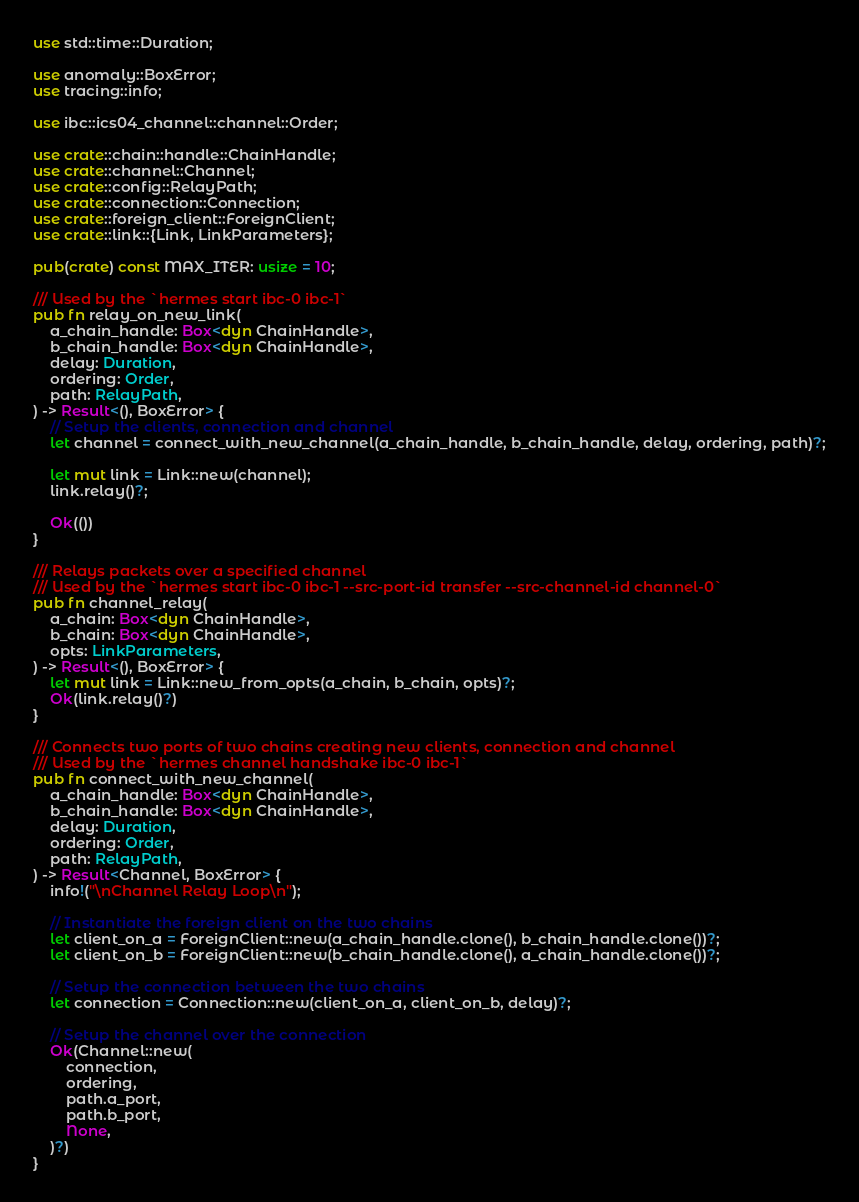<code> <loc_0><loc_0><loc_500><loc_500><_Rust_>use std::time::Duration;

use anomaly::BoxError;
use tracing::info;

use ibc::ics04_channel::channel::Order;

use crate::chain::handle::ChainHandle;
use crate::channel::Channel;
use crate::config::RelayPath;
use crate::connection::Connection;
use crate::foreign_client::ForeignClient;
use crate::link::{Link, LinkParameters};

pub(crate) const MAX_ITER: usize = 10;

/// Used by the `hermes start ibc-0 ibc-1`
pub fn relay_on_new_link(
    a_chain_handle: Box<dyn ChainHandle>,
    b_chain_handle: Box<dyn ChainHandle>,
    delay: Duration,
    ordering: Order,
    path: RelayPath,
) -> Result<(), BoxError> {
    // Setup the clients, connection and channel
    let channel = connect_with_new_channel(a_chain_handle, b_chain_handle, delay, ordering, path)?;

    let mut link = Link::new(channel);
    link.relay()?;

    Ok(())
}

/// Relays packets over a specified channel
/// Used by the `hermes start ibc-0 ibc-1 --src-port-id transfer --src-channel-id channel-0`
pub fn channel_relay(
    a_chain: Box<dyn ChainHandle>,
    b_chain: Box<dyn ChainHandle>,
    opts: LinkParameters,
) -> Result<(), BoxError> {
    let mut link = Link::new_from_opts(a_chain, b_chain, opts)?;
    Ok(link.relay()?)
}

/// Connects two ports of two chains creating new clients, connection and channel
/// Used by the `hermes channel handshake ibc-0 ibc-1`
pub fn connect_with_new_channel(
    a_chain_handle: Box<dyn ChainHandle>,
    b_chain_handle: Box<dyn ChainHandle>,
    delay: Duration,
    ordering: Order,
    path: RelayPath,
) -> Result<Channel, BoxError> {
    info!("\nChannel Relay Loop\n");

    // Instantiate the foreign client on the two chains
    let client_on_a = ForeignClient::new(a_chain_handle.clone(), b_chain_handle.clone())?;
    let client_on_b = ForeignClient::new(b_chain_handle.clone(), a_chain_handle.clone())?;

    // Setup the connection between the two chains
    let connection = Connection::new(client_on_a, client_on_b, delay)?;

    // Setup the channel over the connection
    Ok(Channel::new(
        connection,
        ordering,
        path.a_port,
        path.b_port,
        None,
    )?)
}
</code> 